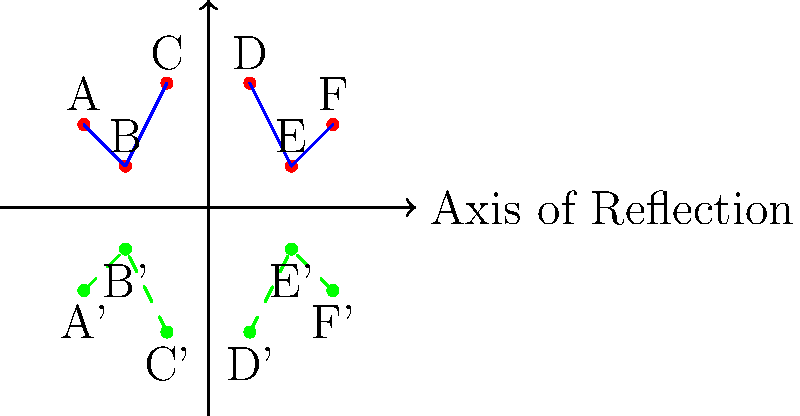In the Maple Story skill tree diagram, nodes A, B, and C represent a chain of skills that synergize well together. After reflecting the entire skill tree across the x-axis, which new skill chain is revealed that might have hidden synergies similar to A-B-C? To solve this problem, we need to follow these steps:

1. Identify the original skill chain A-B-C in the upper left quadrant of the diagram.

2. Understand that reflection across the x-axis means that y-coordinates will be negated while x-coordinates remain the same.

3. Observe the reflected skill tree (shown in green, dashed lines) in the lower half of the diagram.

4. Look for a chain of three skills in the reflected tree that mirrors the pattern of A-B-C.

5. We can see that nodes D', E', and F' form a similar chain in the reflected skill tree.

6. The chain D'-E'-F' is in the same relative position in the lower right quadrant as A-B-C is in the upper left quadrant.

7. This symmetry suggests that the skills represented by D, E, and F might have hidden synergies when used together, similar to how A, B, and C work well together.

8. Therefore, the new skill chain that is revealed through reflection and might have hidden synergies is D-E-F.
Answer: D-E-F 